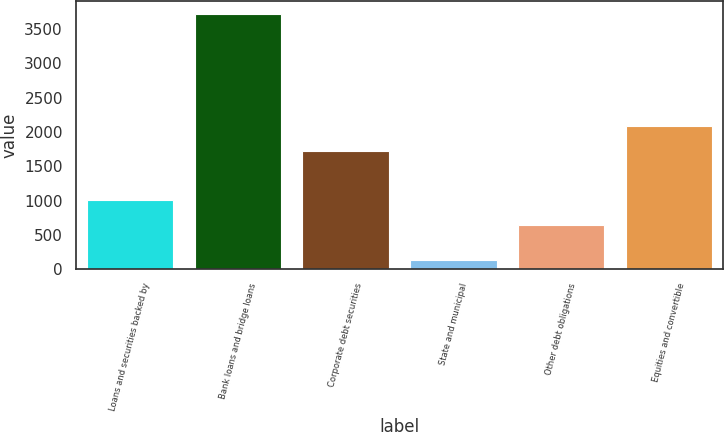Convert chart. <chart><loc_0><loc_0><loc_500><loc_500><bar_chart><fcel>Loans and securities backed by<fcel>Bank loans and bridge loans<fcel>Corporate debt securities<fcel>State and municipal<fcel>Other debt obligations<fcel>Equities and convertible<nl><fcel>1007.1<fcel>3725<fcel>1725.3<fcel>134<fcel>648<fcel>2084.4<nl></chart> 